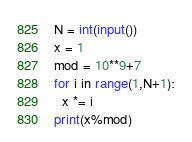Convert code to text. <code><loc_0><loc_0><loc_500><loc_500><_Python_>N = int(input())
x = 1
mod = 10**9+7
for i in range(1,N+1):
  x *= i
print(x%mod)</code> 